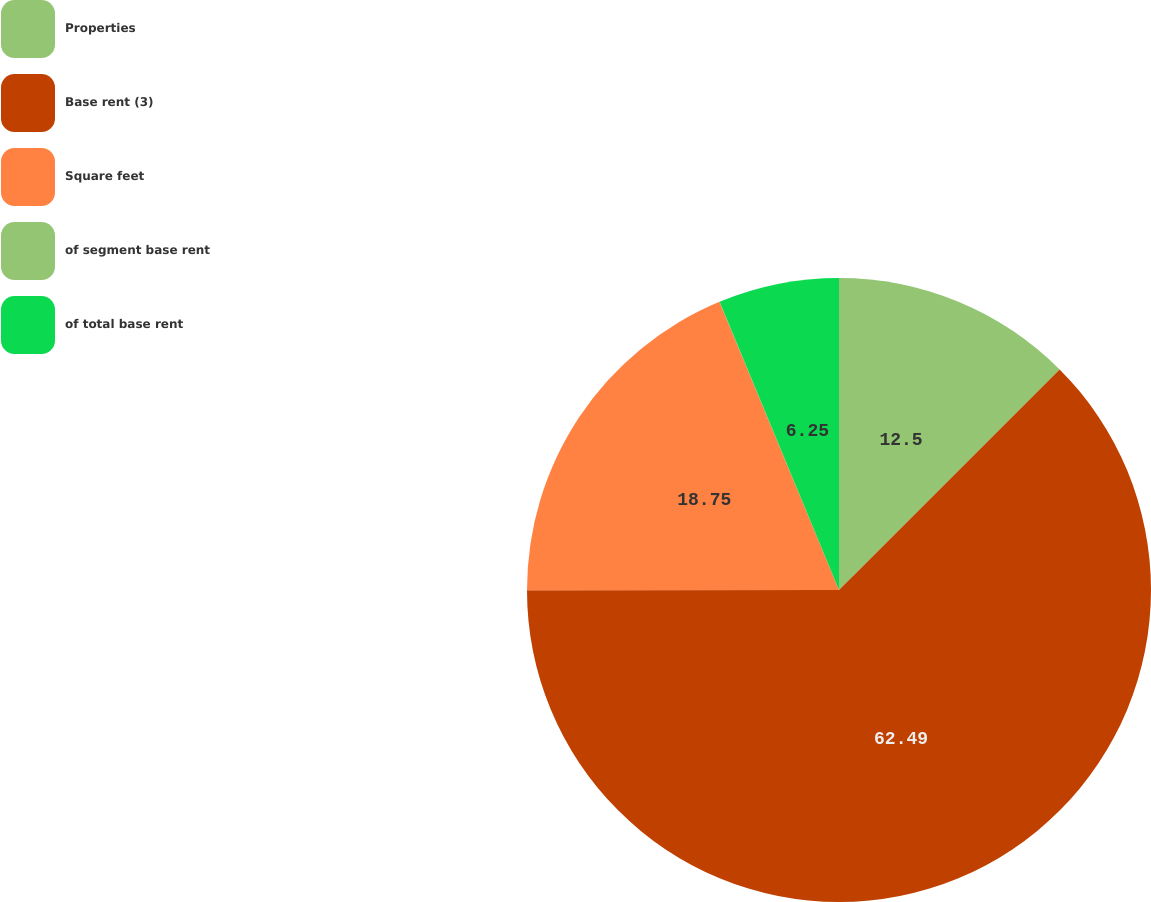Convert chart. <chart><loc_0><loc_0><loc_500><loc_500><pie_chart><fcel>Properties<fcel>Base rent (3)<fcel>Square feet<fcel>of segment base rent<fcel>of total base rent<nl><fcel>12.5%<fcel>62.49%<fcel>18.75%<fcel>0.01%<fcel>6.25%<nl></chart> 